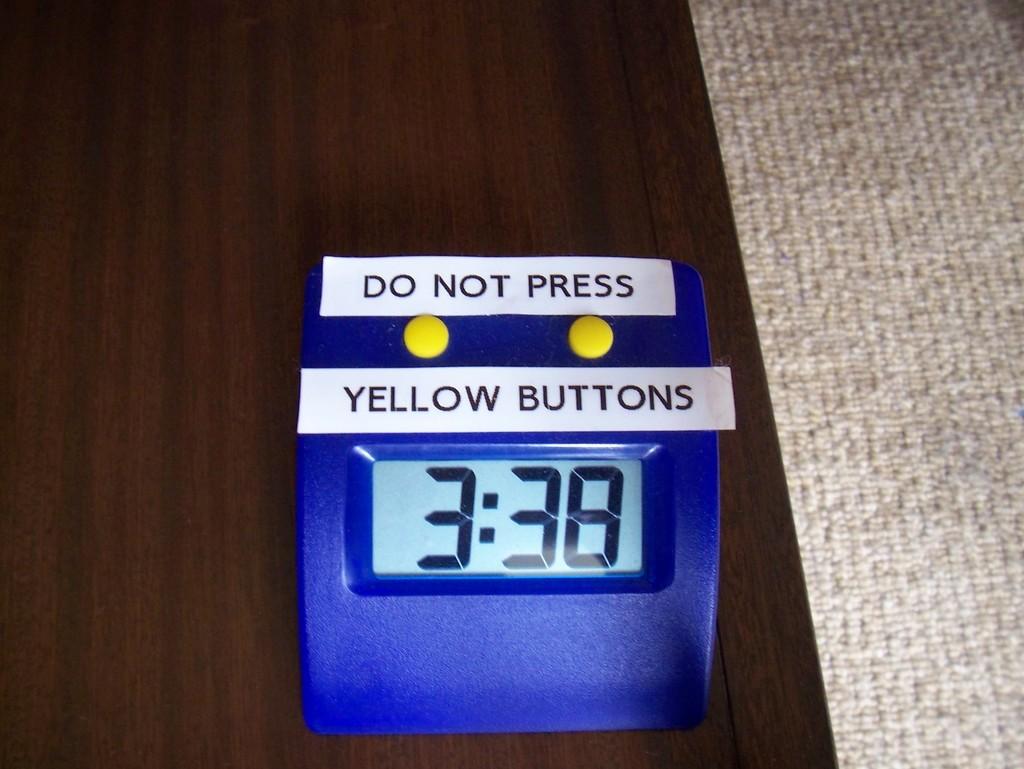What button should not be pressed?
Make the answer very short. Yellow buttons. Is there a warning on the clock?
Provide a short and direct response. Yes. 